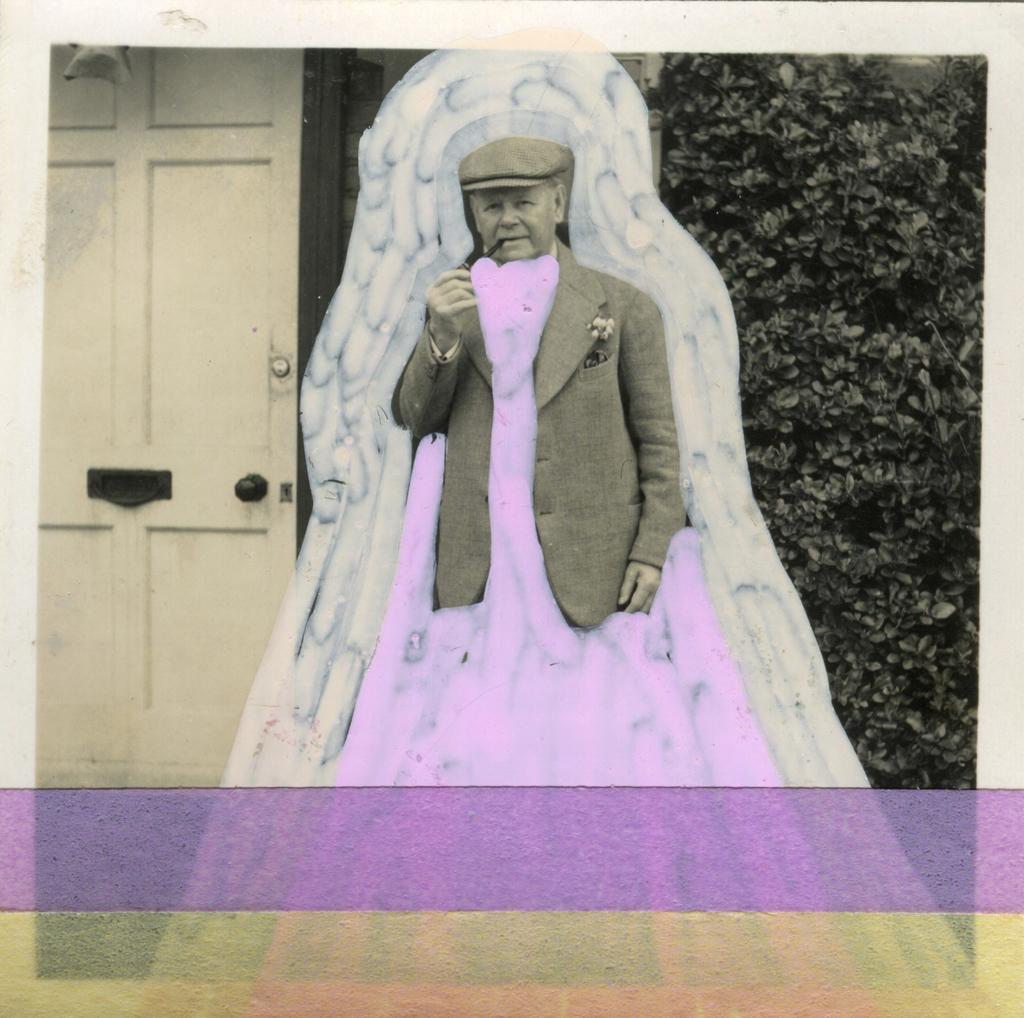What is the main subject of the image? There is a person in the image. Can you describe the person's attire? The person is wearing a blazer and a cap. What is the person holding in his hand? The person is holding an object in his hand. What can be seen in the background of the image? There are trees, a door, and some objects visible in the background of the image. What color is the egg on the island in the image? There is no egg or island present in the image. What type of color can be seen on the person's blazer? The provided facts do not mention the color of the person's blazer, so we cannot answer this question definitively. 